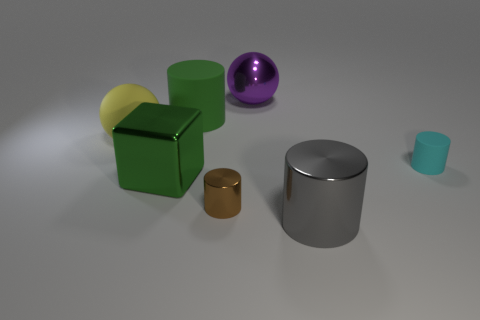How many brown things are either large rubber cylinders or tiny shiny cylinders?
Give a very brief answer. 1. There is a big metal cylinder; are there any shiny things to the right of it?
Ensure brevity in your answer.  No. What size is the yellow matte ball?
Your response must be concise. Large. There is a gray metal thing that is the same shape as the small brown metallic object; what size is it?
Ensure brevity in your answer.  Large. There is a big block in front of the small rubber cylinder; how many brown objects are on the left side of it?
Ensure brevity in your answer.  0. Is the object that is on the right side of the large gray metallic object made of the same material as the large cylinder that is left of the gray shiny thing?
Your response must be concise. Yes. How many green metallic objects are the same shape as the brown object?
Provide a succinct answer. 0. What number of big matte objects are the same color as the shiny block?
Offer a very short reply. 1. There is a small rubber thing right of the yellow object; does it have the same shape as the small object left of the gray shiny cylinder?
Give a very brief answer. Yes. There is a large green thing behind the matte object on the right side of the brown cylinder; how many green things are in front of it?
Offer a very short reply. 1. 